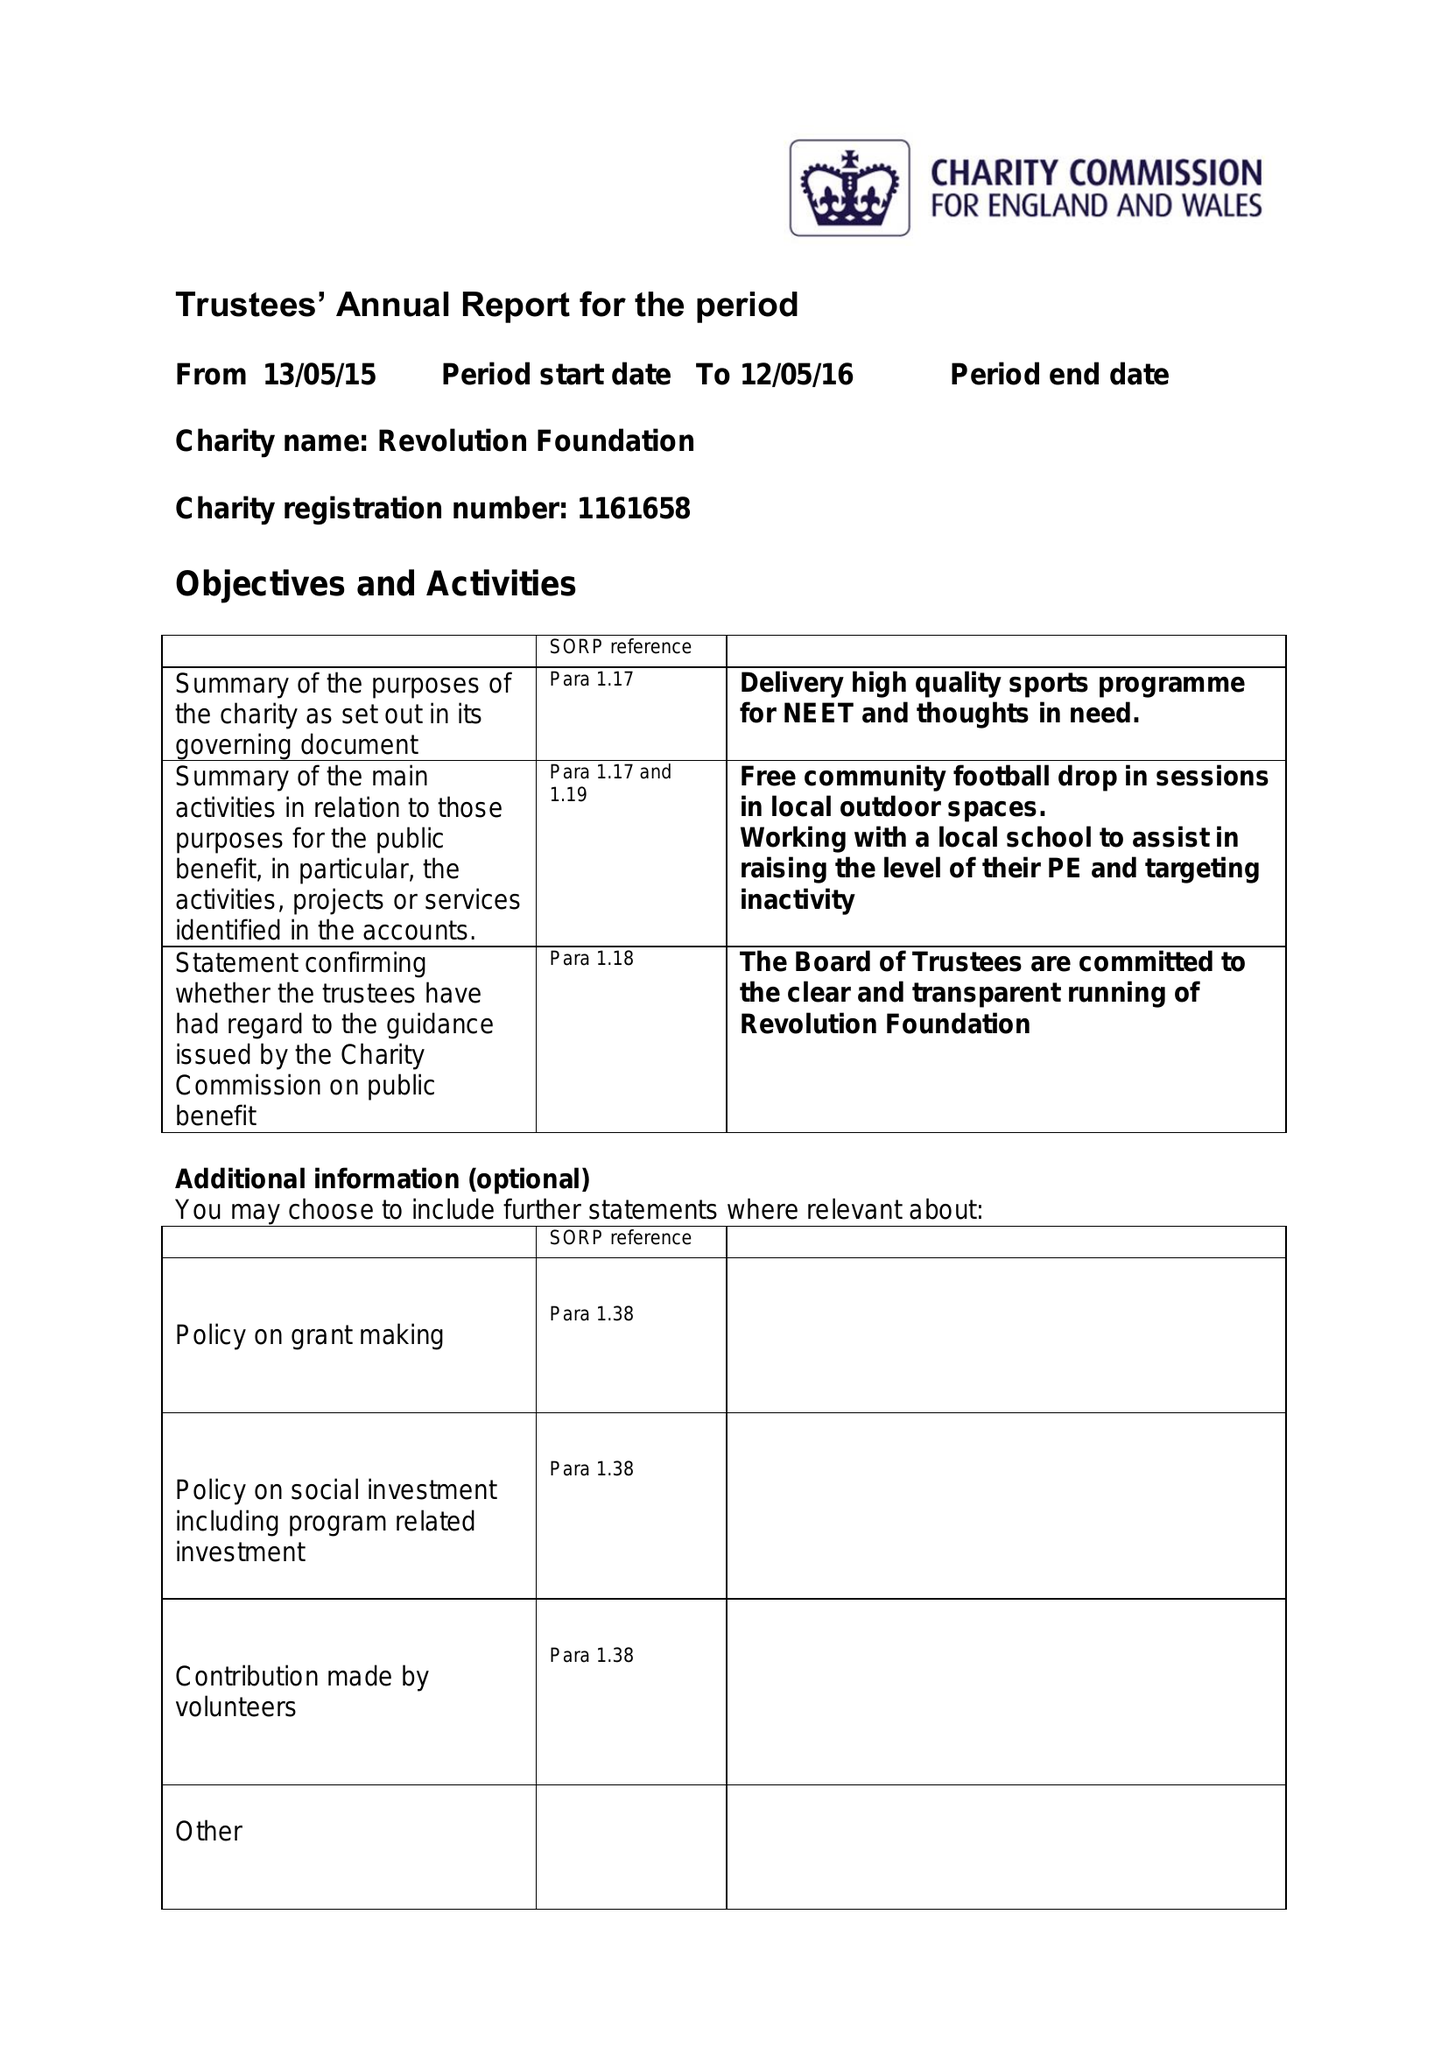What is the value for the address__post_town?
Answer the question using a single word or phrase. ERITH 